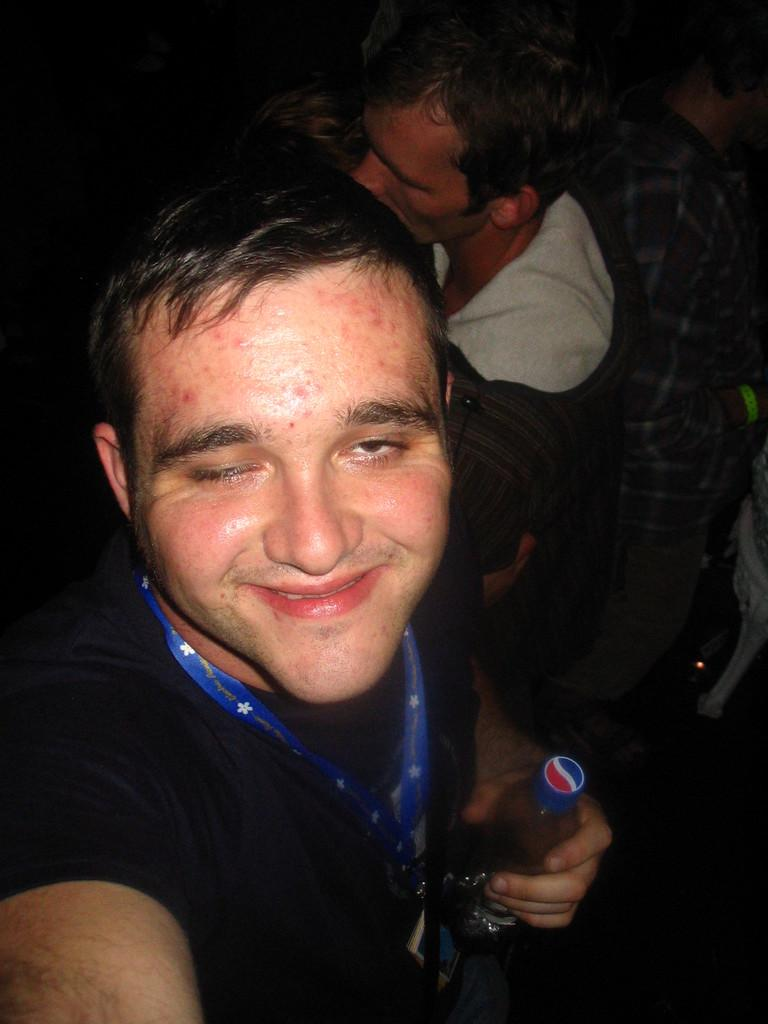What are the people in the image wearing? The people in the image are wearing clothes. Can you describe any specific accessory or item one of the people is wearing? One person is wearing an identity card. What is the person with the identity card holding in his hand? The person with the identity card is holding a bottle in his hand. How is the person with the identity card feeling? The person with the identity card is smiling. What is the reason for the person with the thumb in the image? There is no person with a thumb in the image, so it's not possible to determine the reason for it. 